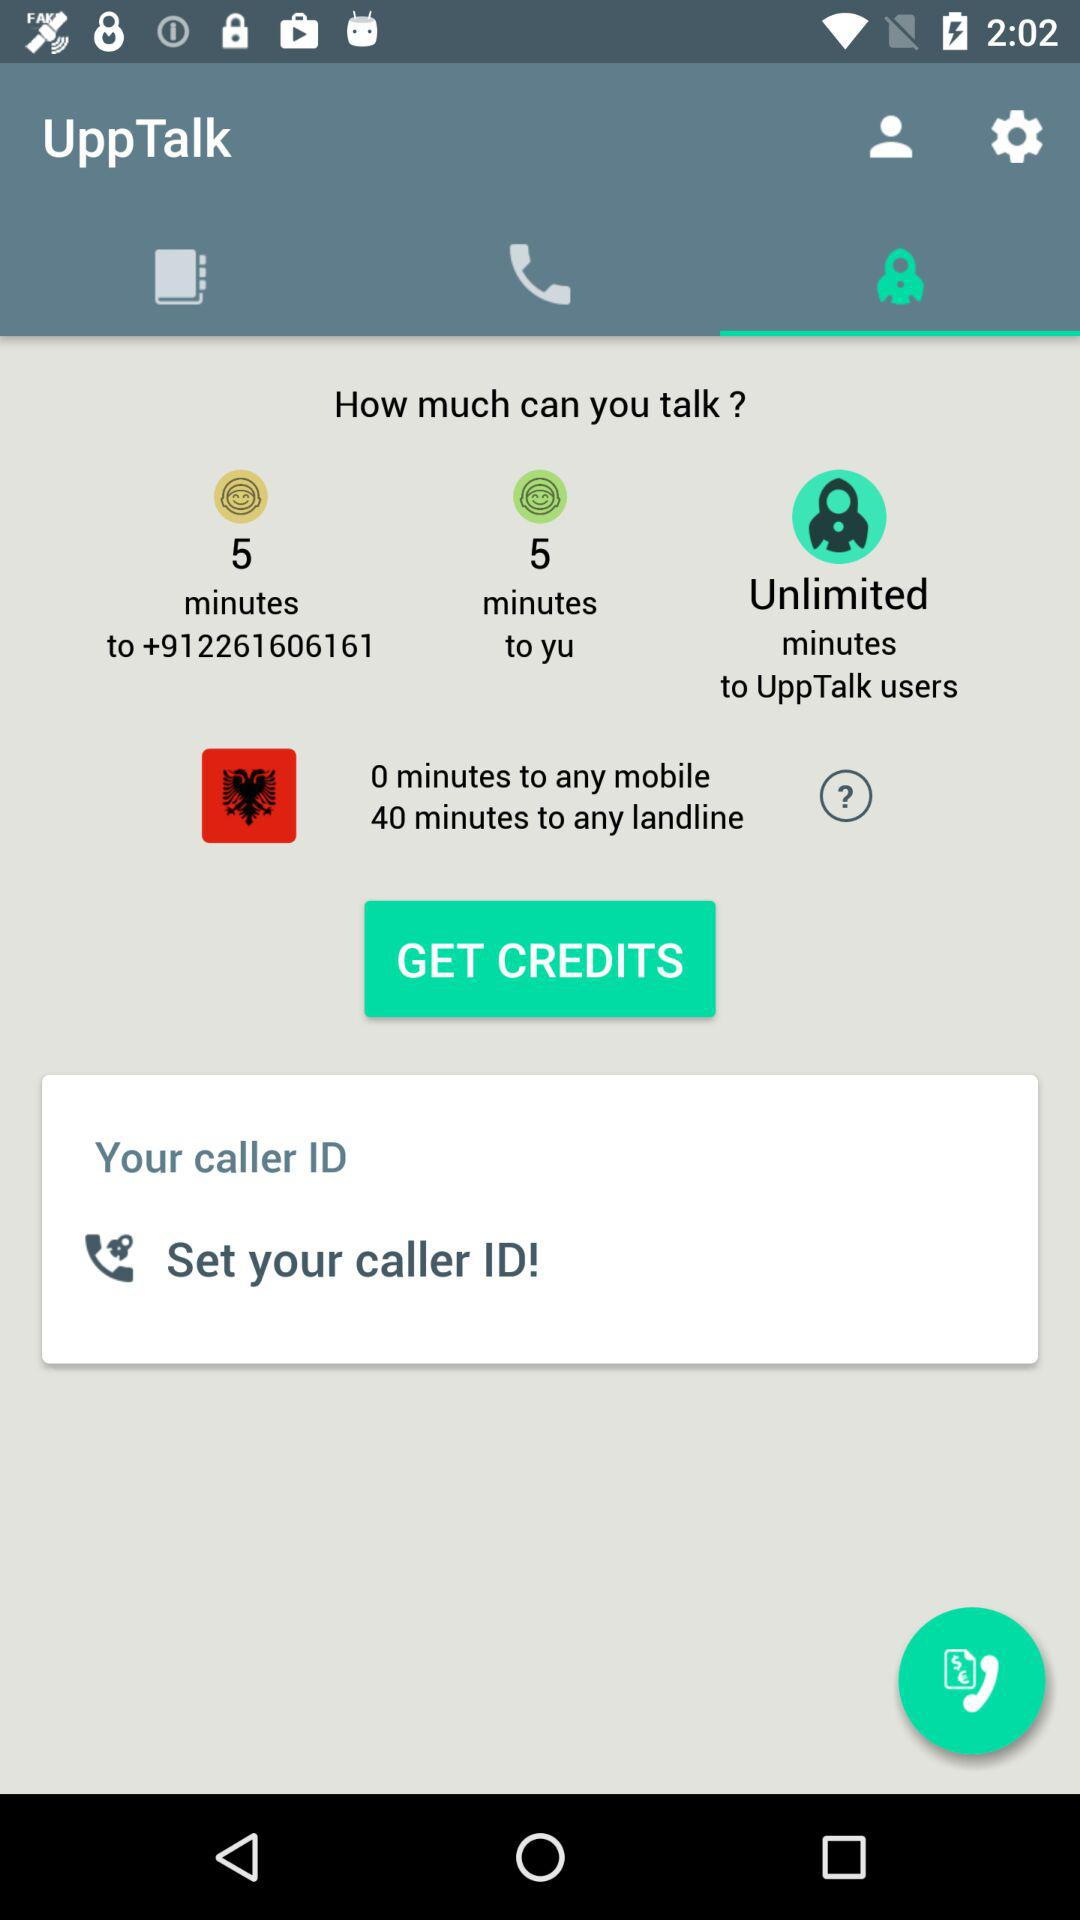Which users have access to unlimited minutes? Users of "UppTalk" have access to unlimited minutes. 